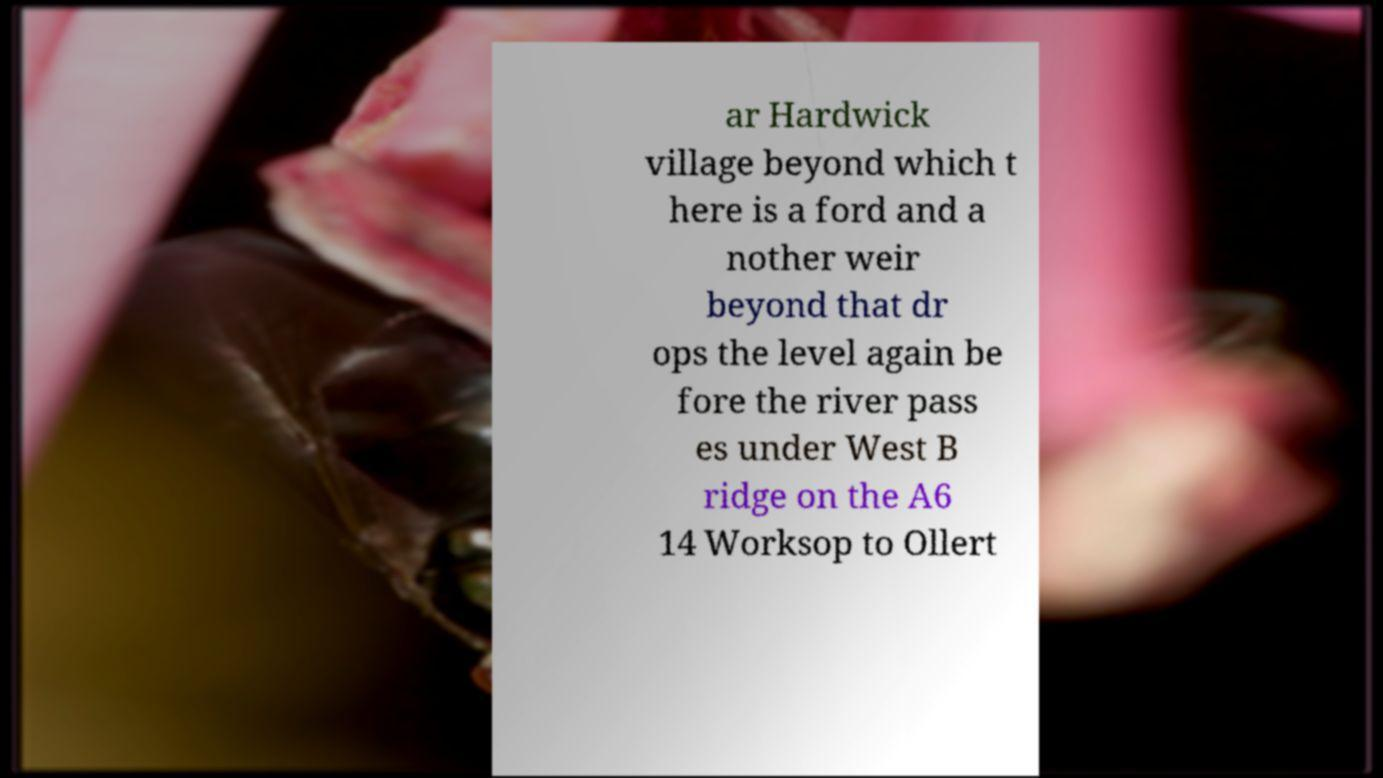For documentation purposes, I need the text within this image transcribed. Could you provide that? ar Hardwick village beyond which t here is a ford and a nother weir beyond that dr ops the level again be fore the river pass es under West B ridge on the A6 14 Worksop to Ollert 